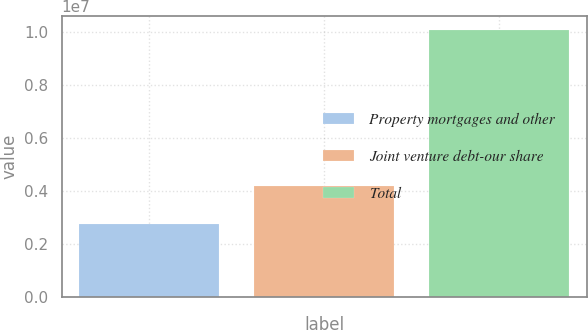<chart> <loc_0><loc_0><loc_500><loc_500><bar_chart><fcel>Property mortgages and other<fcel>Joint venture debt-our share<fcel>Total<nl><fcel>2.77518e+06<fcel>4.18429e+06<fcel>1.00903e+07<nl></chart> 